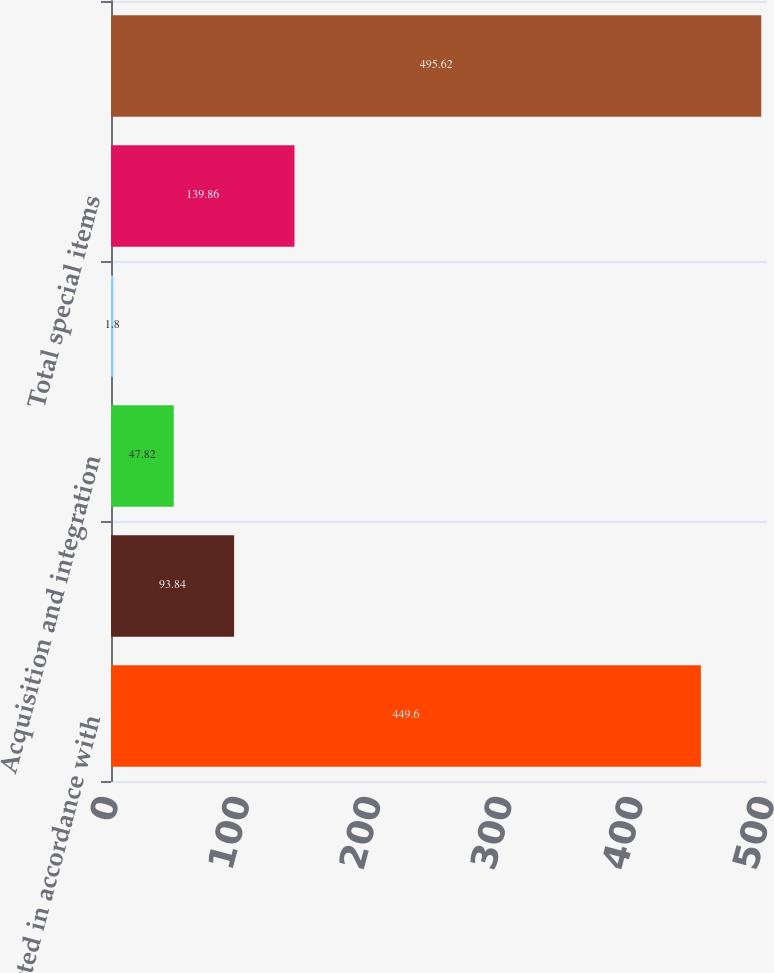<chart> <loc_0><loc_0><loc_500><loc_500><bar_chart><fcel>As reported in accordance with<fcel>Facilities closure and other<fcel>Acquisition and integration<fcel>Ceased production of market<fcel>Total special items<fcel>Excluding special items<nl><fcel>449.6<fcel>93.84<fcel>47.82<fcel>1.8<fcel>139.86<fcel>495.62<nl></chart> 